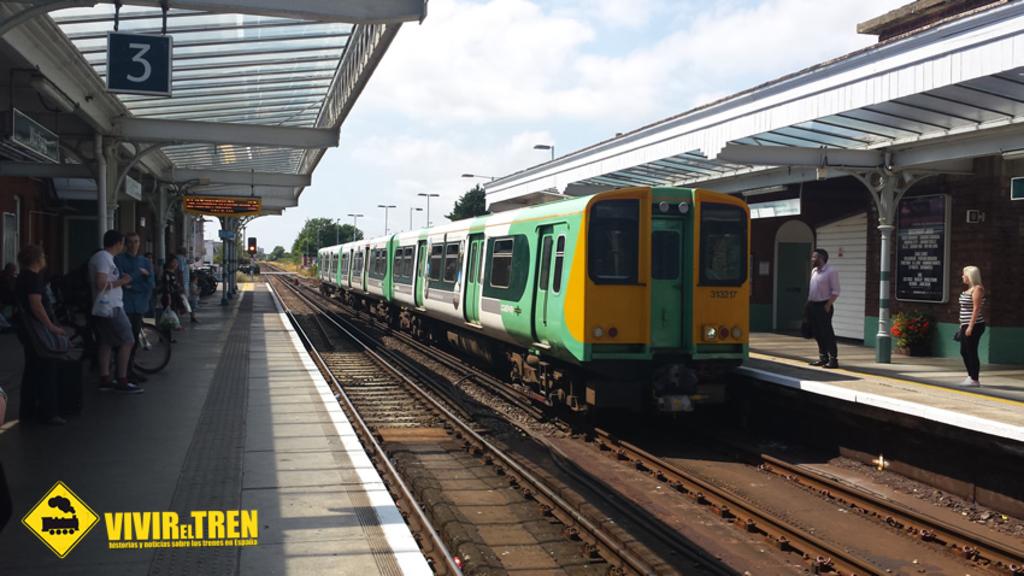Which station number is this?
Provide a succinct answer. 3. What is the train company?
Provide a succinct answer. Vivir el tren. 